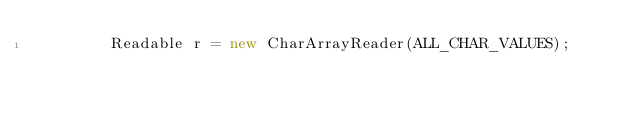<code> <loc_0><loc_0><loc_500><loc_500><_Java_>        Readable r = new CharArrayReader(ALL_CHAR_VALUES);</code> 